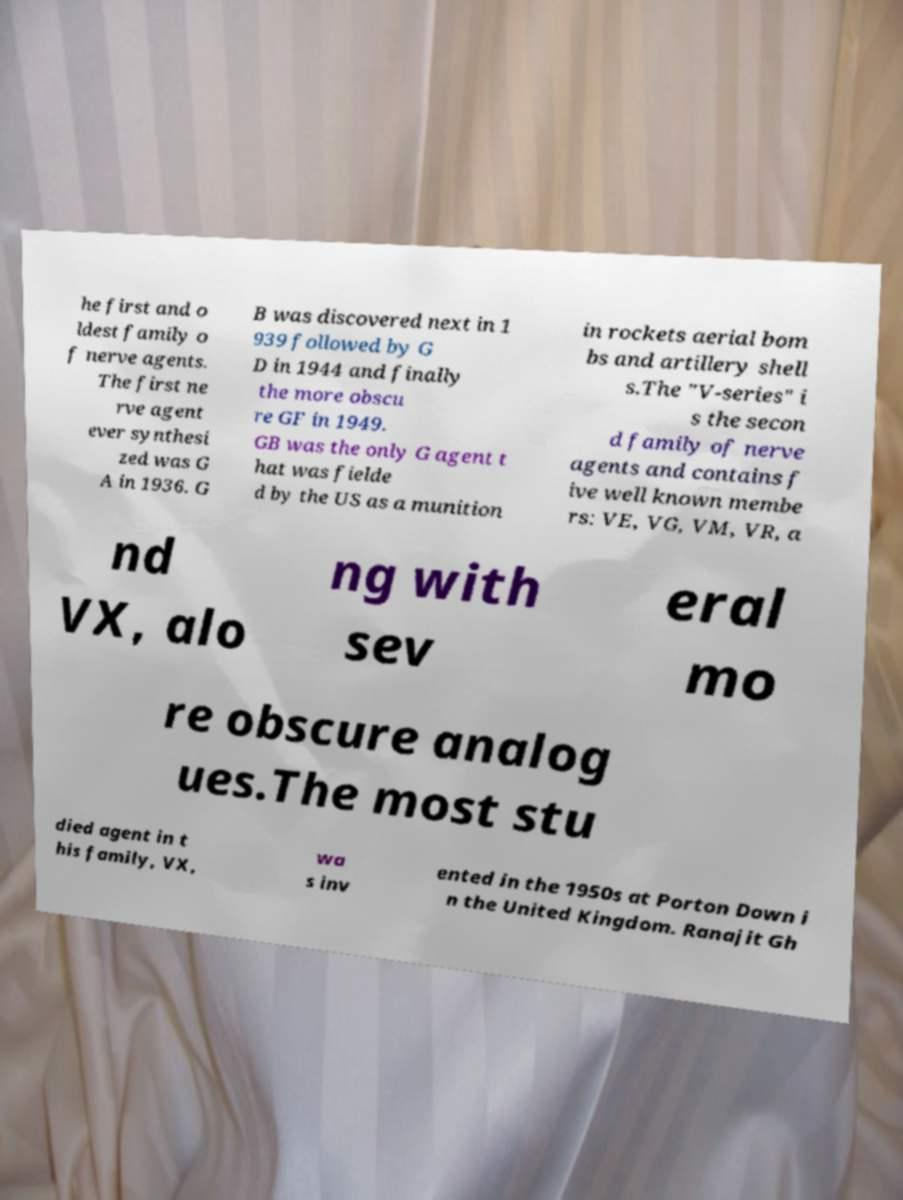There's text embedded in this image that I need extracted. Can you transcribe it verbatim? he first and o ldest family o f nerve agents. The first ne rve agent ever synthesi zed was G A in 1936. G B was discovered next in 1 939 followed by G D in 1944 and finally the more obscu re GF in 1949. GB was the only G agent t hat was fielde d by the US as a munition in rockets aerial bom bs and artillery shell s.The "V-series" i s the secon d family of nerve agents and contains f ive well known membe rs: VE, VG, VM, VR, a nd VX, alo ng with sev eral mo re obscure analog ues.The most stu died agent in t his family, VX, wa s inv ented in the 1950s at Porton Down i n the United Kingdom. Ranajit Gh 